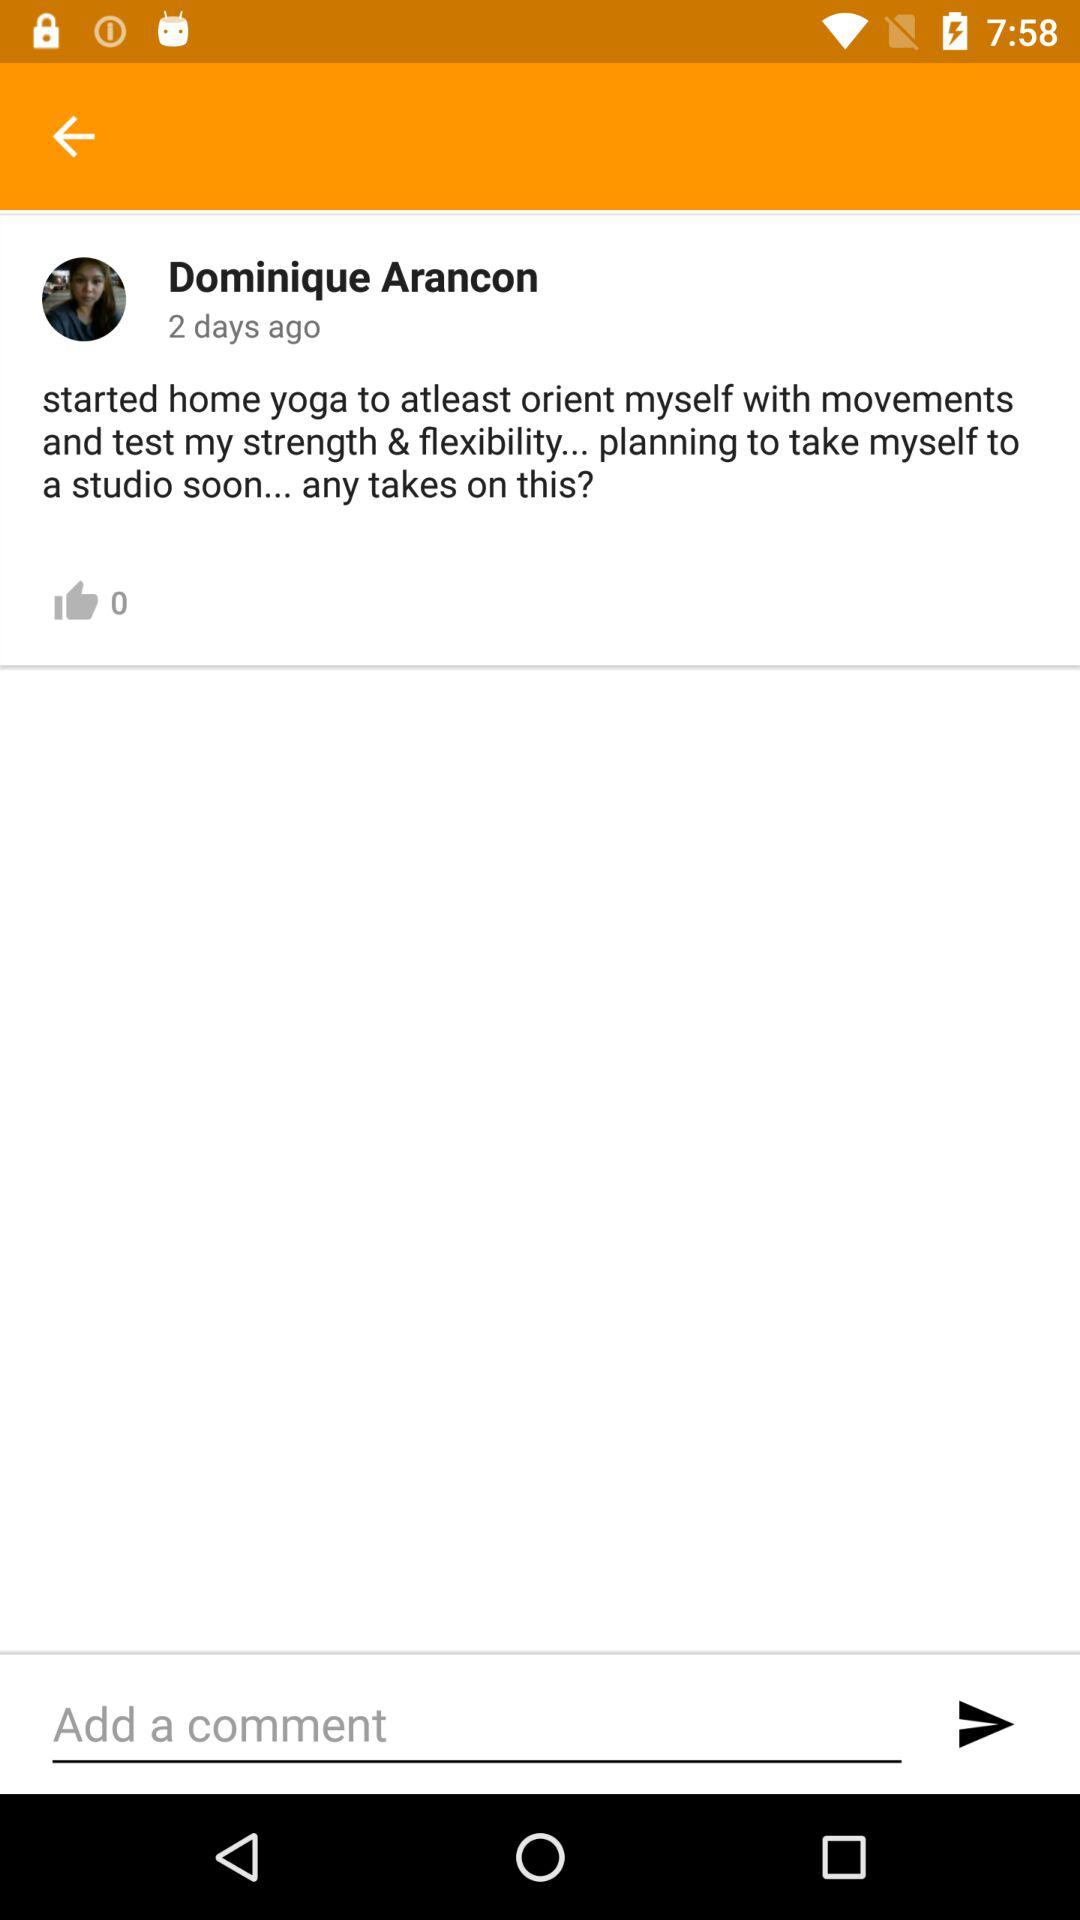What is the time of this post? The time of this post is 2 days ago. 